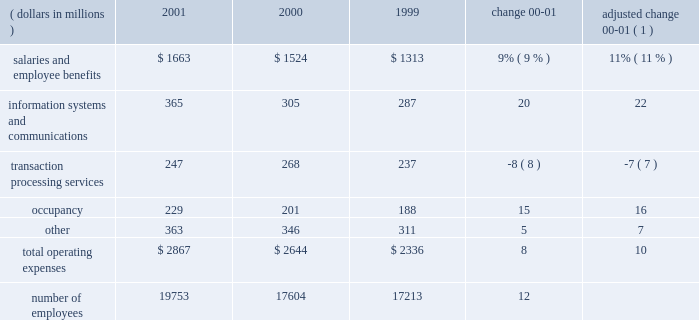Operating expenses operating expenses were $ 2.9 billion , an increase of 8% ( 8 % ) over 2000 .
Adjusted for the formation of citistreet , operating expenses grew 10% ( 10 % ) .
Expense growth in 2001 of 10% ( 10 % ) is significantly lower than the comparable 20% ( 20 % ) expense growth for 2000 compared to 1999 .
State street successfully reduced the growth rate of expenses as revenue growth slowed during the latter half of 2000 and early 2001 .
The expense growth in 2001 reflects higher expenses for salaries and employee benefits , as well as information systems and communications .
O p e r a t i n g e x p e n s e s ( dollars in millions ) 2001 2000 1999 change adjusted change 00-01 ( 1 ) .
( 1 ) 2000 results adjusted for the formation of citistreet expenses related to salaries and employee benefits increased $ 139million in 2001 , or $ 163millionwhen adjusted for the formation of citistreet .
The adjusted increase reflects more than 2100 additional staff to support the large client wins and new business from existing clients and acquisitions .
This expense increase was partially offset by lower incentive-based compensation .
Information systems and communications expense was $ 365 million in 2001 , up 20% ( 20 % ) from the prior year .
Adjusted for the formation of citistreet , information systems and communications expense increased 22% ( 22 % ) .
This growth reflects both continuing investment in software and hardware , aswell as the technology costs associated with increased staffing levels .
Expenses related to transaction processing services were $ 247 million , down $ 21 million , or 8% ( 8 % ) .
These expenses are volume related and include external contract services , subcustodian fees , brokerage services and fees related to securities settlement .
Lower mutual fund shareholder activities , and lower subcustodian fees resulting from both the decline in asset values and lower transaction volumes , drove the decline .
Occupancy expensewas $ 229million , up 15% ( 15 % ) .
The increase is due to expenses necessary to support state street 2019s global growth , and expenses incurred for leasehold improvements and other operational costs .
Other expenses were $ 363 million , up $ 17 million , or 5% ( 5 % ) .
These expenses include professional services , advertising and sales promotion , and internal operational expenses .
The increase over prior year is due to a $ 21 million increase in the amortization of goodwill , primarily from acquisitions in 2001 .
In accordance with recent accounting pronouncements , goodwill amortization expense will be eliminated in 2002 .
State street recorded approximately $ 38 million , or $ .08 per share after tax , of goodwill amortization expense in 2001 .
State street 2019s cost containment efforts , which reduced discretionary spending , partially offset the increase in other expenses .
State street corporation 9 .
What was the value , in billions of dollars , of operating expenses in 2000? 
Computations: (2.9 / (100 + 8%))
Answer: 0.02898. 